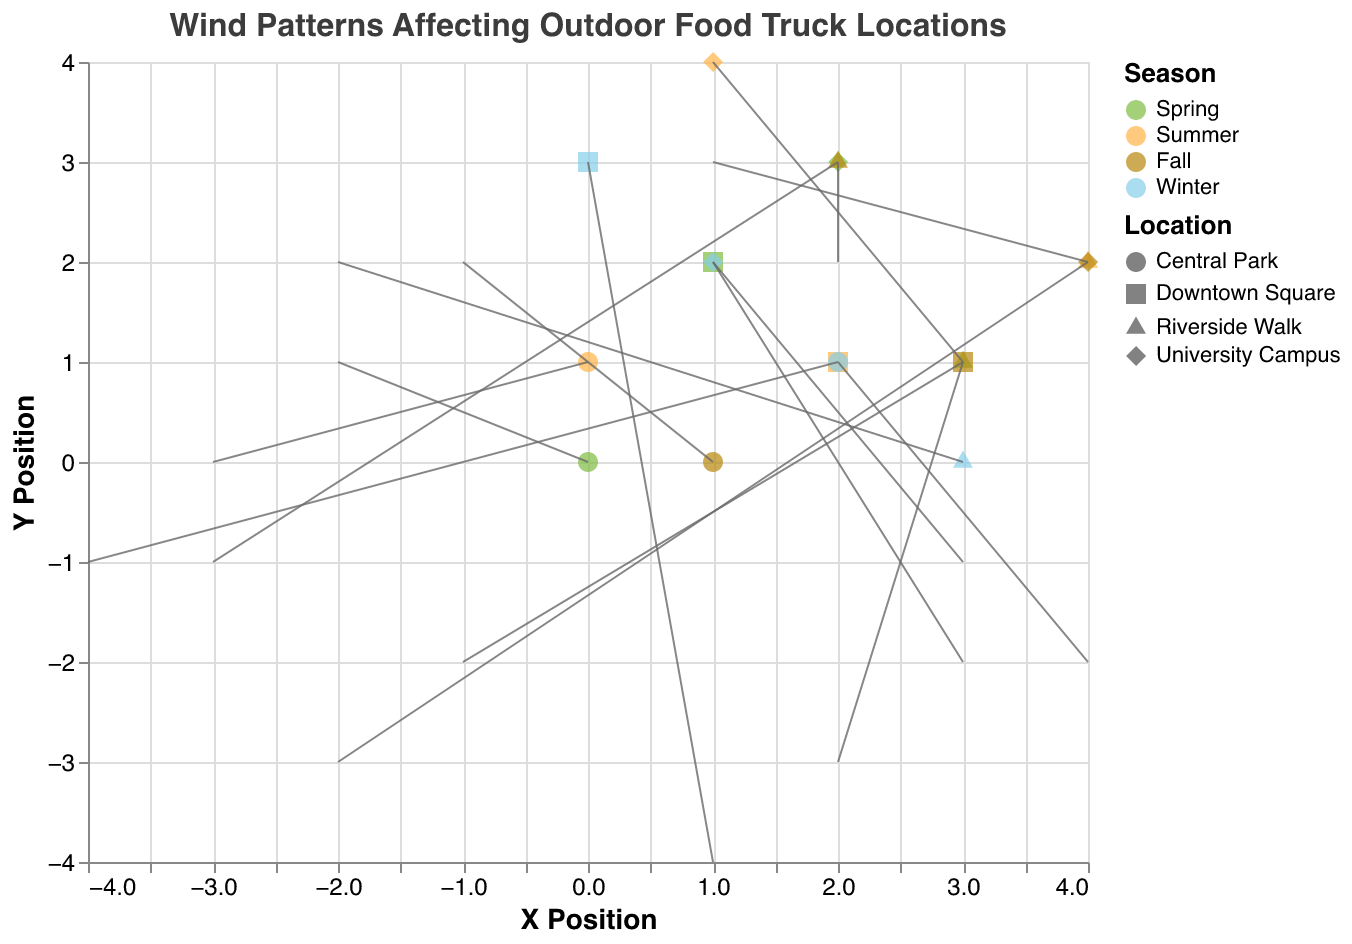What's the title of the plot? The title is prominently displayed at the top of the plot in bold, detailing the overall subject matter. It reads "Wind Patterns Affecting Outdoor Food Truck Locations".
Answer: Wind Patterns Affecting Outdoor Food Truck Locations Which season has the most data points? By counting the number of data points represented by the markers (points, circles, etc.) for each season visible in the legend, we see that each season has four data points.
Answer: All seasons have equal data points What shape represents Downtown Square locations? The legend indicates the mapping between shapes and locations. The square shape represents Downtown Square.
Answer: Square In which season does Central Park experience the strongest wind? Look at the lengths of arrows starting from Central Park in each season. The longer the arrow, the stronger the wind. In Summer, the arrow length is the longest (3 units).
Answer: Summer What is the direction of the wind in Riverside Walk during Fall? Follow the arrow originating from Riverside Walk for Fall in the plot. The arrow points to the left and slightly downward (U: -3, V: -1).
Answer: Left and slightly downward Compare wind patterns in Downton Square for Winter and Spring. Which season has a stronger wind? The strength of the wind is indicated by the arrow length; compare the lengths starting at Downtown Square for Winter and Spring. In Winter, the arrow has a length \( \sqrt{1^2 + (-4)^2} = \sqrt{17} \approx 4.12 \). For Spring, it's \( \sqrt{3^2 + (-1)^2} = \sqrt{10} \approx 3.16 \).
Answer: Winter What's the average direction (U and V components) of wind at University Campus? Average the U and V values at University Campus across all seasons: Spring (U: 2, V:2), Summer (U: 3, V:1), Fall (U: 1, V:3), Winter (U: 3, V:-2). Average U = (2+3+1+3)/4 = 2.25; Average V = (2+1+3-2)/4 = 1.
Answer: U: 2.25, V: 1 Which location experiences the most varied wind patterns? Look for varying arrow directions and lengths across seasons for each location. Riverside Walk shows significant variety in wind directions and strengths across seasons.
Answer: Riverside Walk In which season is the wind pattern at the University Campus most likely to cause trouble for outdoor activities? Assess the wind strength and direction at University Campus, considering strong adverse directions are problematic. The Winter season shows wind with components (U: 3, V: -2), suggesting strong and potentially troubling wind patterns.
Answer: Winter Is there a seasonal trend for strong winds in Central Park? Examine the arrow lengths at Central Park for each season. Noticeable lengths indicating stronger winds appear in Summer and Winter.
Answer: Yes, in Summer and Winter 